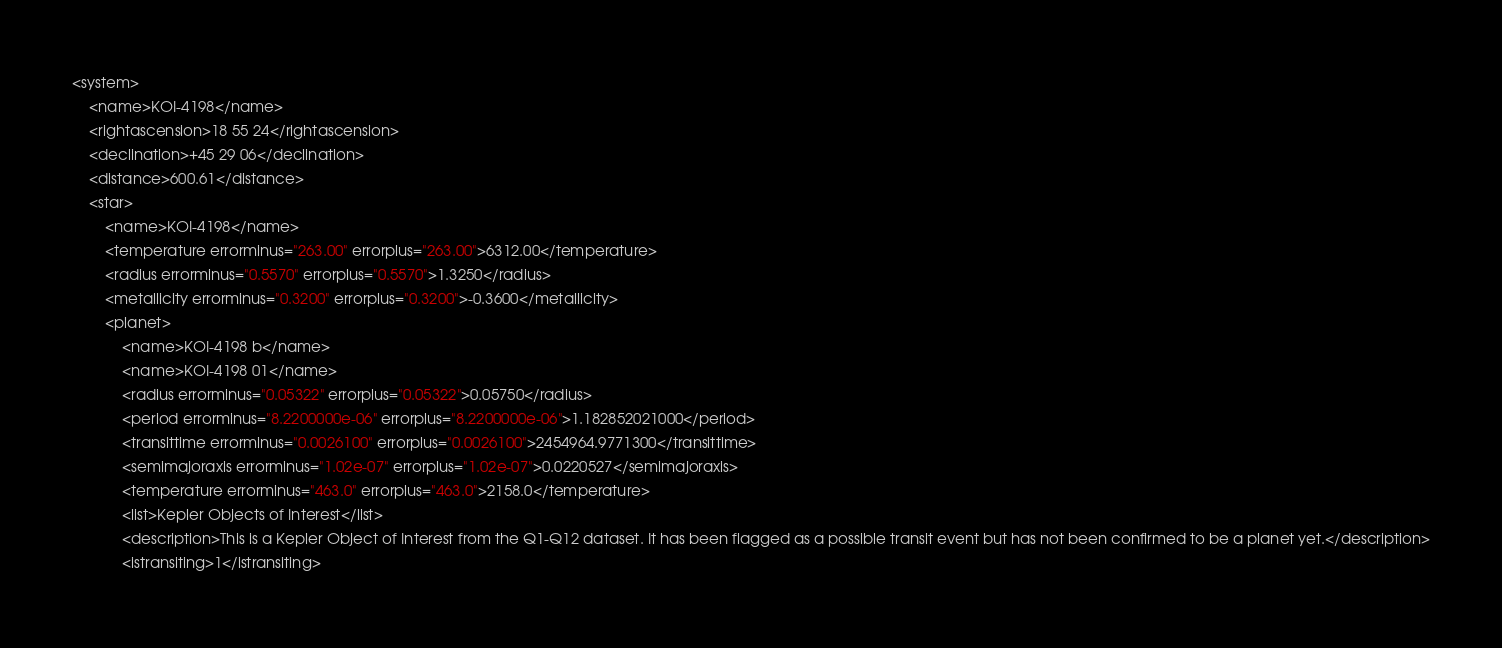Convert code to text. <code><loc_0><loc_0><loc_500><loc_500><_XML_><system>
	<name>KOI-4198</name>
	<rightascension>18 55 24</rightascension>
	<declination>+45 29 06</declination>
	<distance>600.61</distance>
	<star>
		<name>KOI-4198</name>
		<temperature errorminus="263.00" errorplus="263.00">6312.00</temperature>
		<radius errorminus="0.5570" errorplus="0.5570">1.3250</radius>
		<metallicity errorminus="0.3200" errorplus="0.3200">-0.3600</metallicity>
		<planet>
			<name>KOI-4198 b</name>
			<name>KOI-4198 01</name>
			<radius errorminus="0.05322" errorplus="0.05322">0.05750</radius>
			<period errorminus="8.2200000e-06" errorplus="8.2200000e-06">1.182852021000</period>
			<transittime errorminus="0.0026100" errorplus="0.0026100">2454964.9771300</transittime>
			<semimajoraxis errorminus="1.02e-07" errorplus="1.02e-07">0.0220527</semimajoraxis>
			<temperature errorminus="463.0" errorplus="463.0">2158.0</temperature>
			<list>Kepler Objects of Interest</list>
			<description>This is a Kepler Object of Interest from the Q1-Q12 dataset. It has been flagged as a possible transit event but has not been confirmed to be a planet yet.</description>
			<istransiting>1</istransiting></code> 